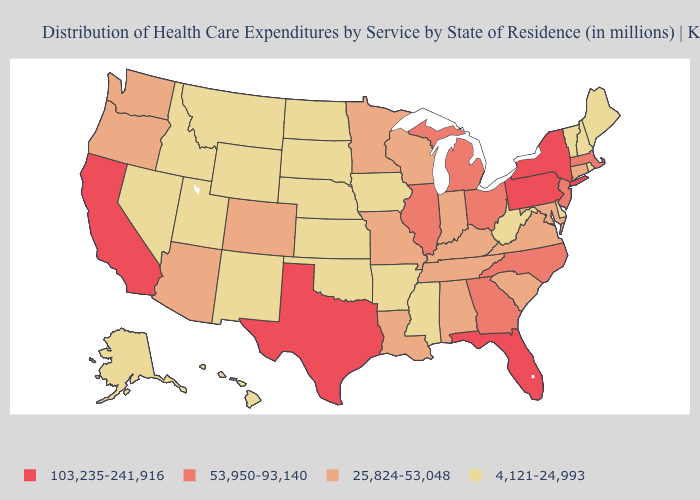Among the states that border Wisconsin , does Iowa have the highest value?
Write a very short answer. No. What is the value of Missouri?
Give a very brief answer. 25,824-53,048. What is the value of Connecticut?
Be succinct. 25,824-53,048. What is the value of Connecticut?
Quick response, please. 25,824-53,048. What is the value of Hawaii?
Keep it brief. 4,121-24,993. What is the value of Pennsylvania?
Keep it brief. 103,235-241,916. Among the states that border Arkansas , which have the lowest value?
Quick response, please. Mississippi, Oklahoma. Does the first symbol in the legend represent the smallest category?
Give a very brief answer. No. Among the states that border Nebraska , which have the lowest value?
Write a very short answer. Iowa, Kansas, South Dakota, Wyoming. Name the states that have a value in the range 4,121-24,993?
Quick response, please. Alaska, Arkansas, Delaware, Hawaii, Idaho, Iowa, Kansas, Maine, Mississippi, Montana, Nebraska, Nevada, New Hampshire, New Mexico, North Dakota, Oklahoma, Rhode Island, South Dakota, Utah, Vermont, West Virginia, Wyoming. What is the value of Massachusetts?
Write a very short answer. 53,950-93,140. Which states have the highest value in the USA?
Answer briefly. California, Florida, New York, Pennsylvania, Texas. Name the states that have a value in the range 53,950-93,140?
Answer briefly. Georgia, Illinois, Massachusetts, Michigan, New Jersey, North Carolina, Ohio. Does the first symbol in the legend represent the smallest category?
Give a very brief answer. No. What is the value of Indiana?
Write a very short answer. 25,824-53,048. 